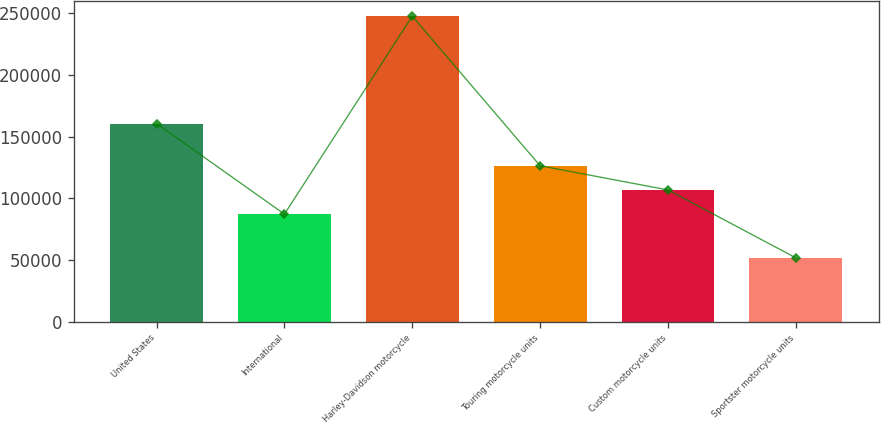Convert chart. <chart><loc_0><loc_0><loc_500><loc_500><bar_chart><fcel>United States<fcel>International<fcel>Harley-Davidson motorcycle<fcel>Touring motorcycle units<fcel>Custom motorcycle units<fcel>Sportster motorcycle units<nl><fcel>160477<fcel>87148<fcel>247625<fcel>126332<fcel>106740<fcel>51704<nl></chart> 